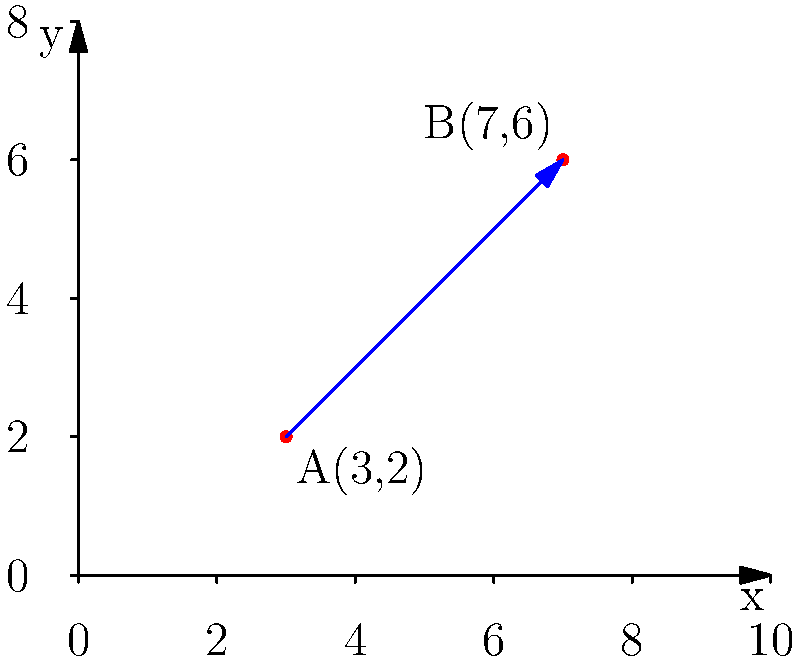As a producer planning the seating arrangement for a VIP screening of your upcoming blockbuster, you want to maximize visibility and comfort. The theater can be represented on a coordinate grid where each unit represents 1 meter. The best viewing angle is along the line connecting points A(3,2) and B(7,6). Calculate the slope of this optimal viewing line to determine the ideal incline for the seating arrangement. Round your answer to two decimal places. To find the slope of the line connecting points A(3,2) and B(7,6), we'll use the slope formula:

$m = \frac{y_2 - y_1}{x_2 - x_1}$

Where $(x_1, y_1)$ is the first point and $(x_2, y_2)$ is the second point.

Step 1: Identify the coordinates
- Point A: $(x_1, y_1) = (3, 2)$
- Point B: $(x_2, y_2) = (7, 6)$

Step 2: Apply the slope formula
$m = \frac{y_2 - y_1}{x_2 - x_1} = \frac{6 - 2}{7 - 3} = \frac{4}{4} = 1$

Step 3: Interpret the result
The slope is exactly 1, which means for every 1 unit increase in x, y also increases by 1 unit.

Step 4: Round to two decimal places
Since the slope is already a whole number, rounding to two decimal places gives us 1.00.

This slope of 1.00 represents the ideal incline for the seating arrangement, ensuring optimal viewing angles for the VIP audience.
Answer: 1.00 